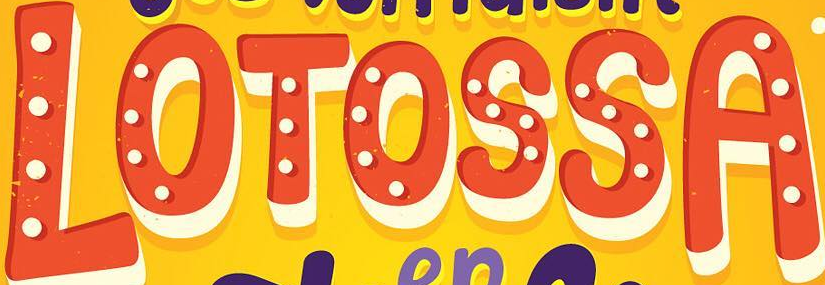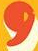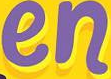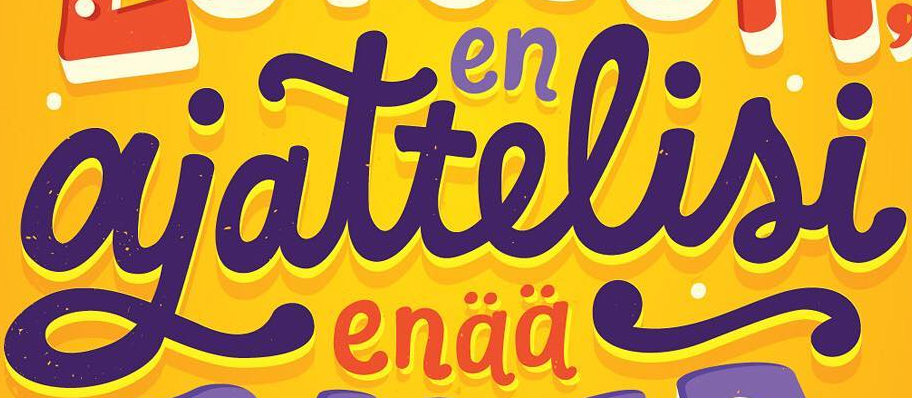What words can you see in these images in sequence, separated by a semicolon? LOTOSSA; ,; en; ajattelisi 